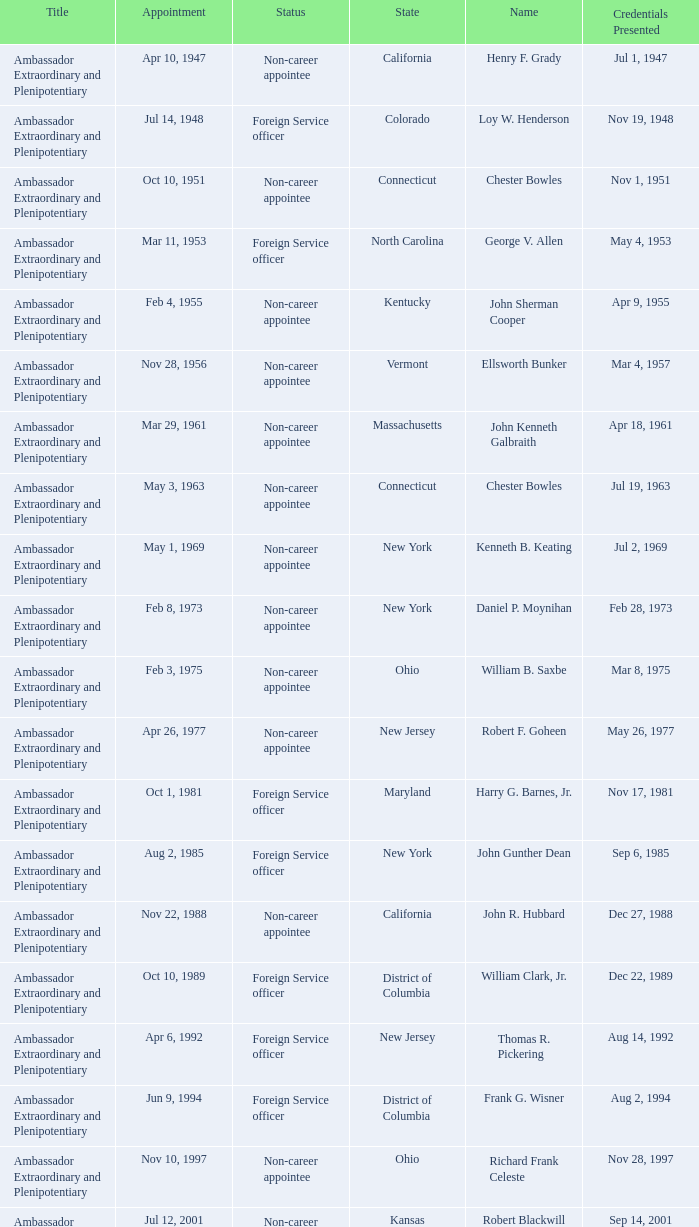What is the title for david campbell mulford? Ambassador Extraordinary and Plenipotentiary. 